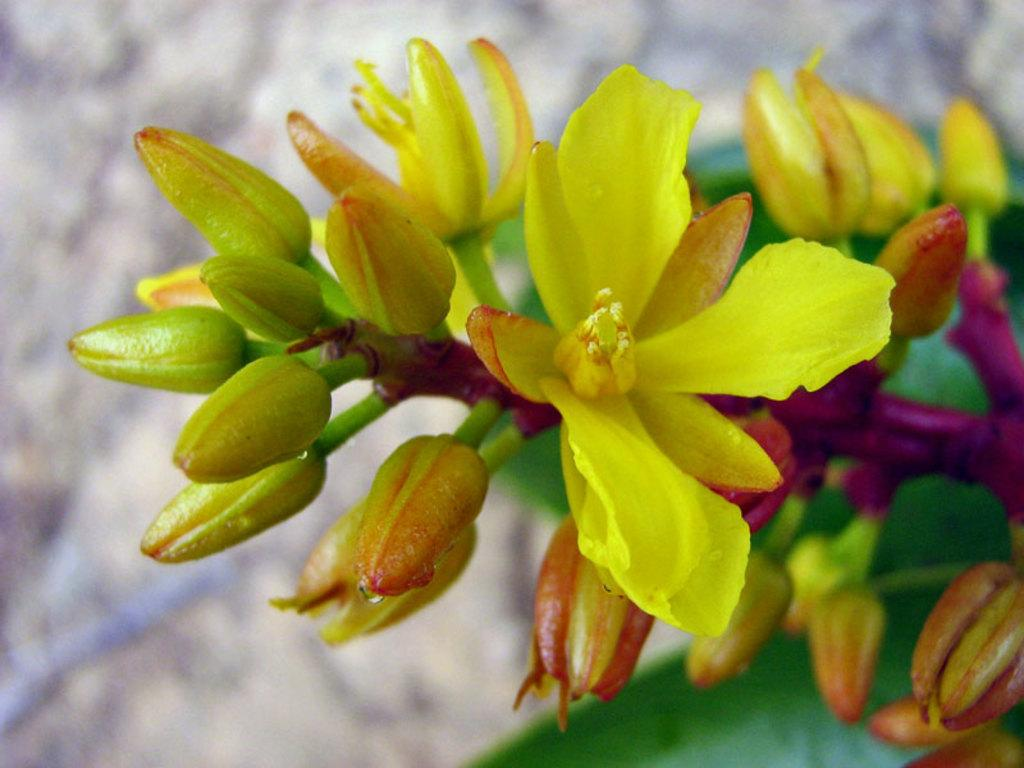What type of plant life is present in the image? There are flowers and buds of a plant in the image. Can you describe the background of the image? The background of the image is blurred. What color is the quill used by the flowers to write their messages in the image? There is no quill or writing activity present in the image; it features flowers and plant buds. 